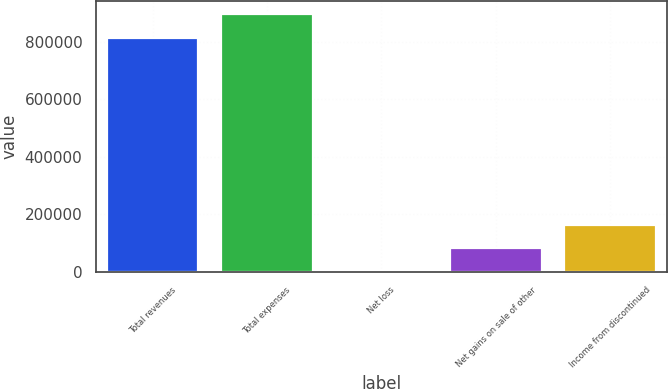<chart> <loc_0><loc_0><loc_500><loc_500><bar_chart><fcel>Total revenues<fcel>Total expenses<fcel>Net loss<fcel>Net gains on sale of other<fcel>Income from discontinued<nl><fcel>813665<fcel>895032<fcel>1554<fcel>82920.5<fcel>164287<nl></chart> 